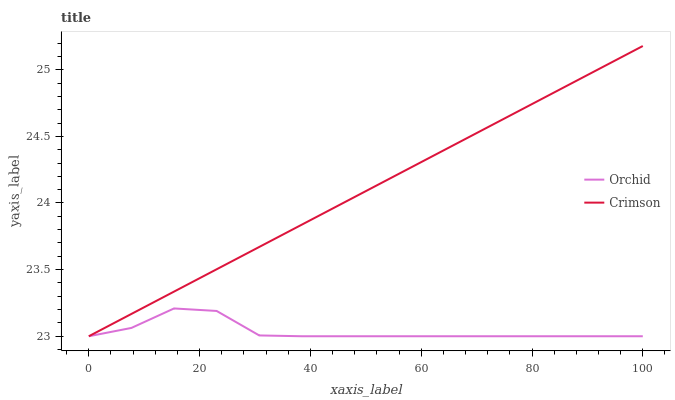Does Orchid have the minimum area under the curve?
Answer yes or no. Yes. Does Crimson have the maximum area under the curve?
Answer yes or no. Yes. Does Orchid have the maximum area under the curve?
Answer yes or no. No. Is Crimson the smoothest?
Answer yes or no. Yes. Is Orchid the roughest?
Answer yes or no. Yes. Is Orchid the smoothest?
Answer yes or no. No. Does Crimson have the highest value?
Answer yes or no. Yes. Does Orchid have the highest value?
Answer yes or no. No. Does Orchid intersect Crimson?
Answer yes or no. Yes. Is Orchid less than Crimson?
Answer yes or no. No. Is Orchid greater than Crimson?
Answer yes or no. No. 